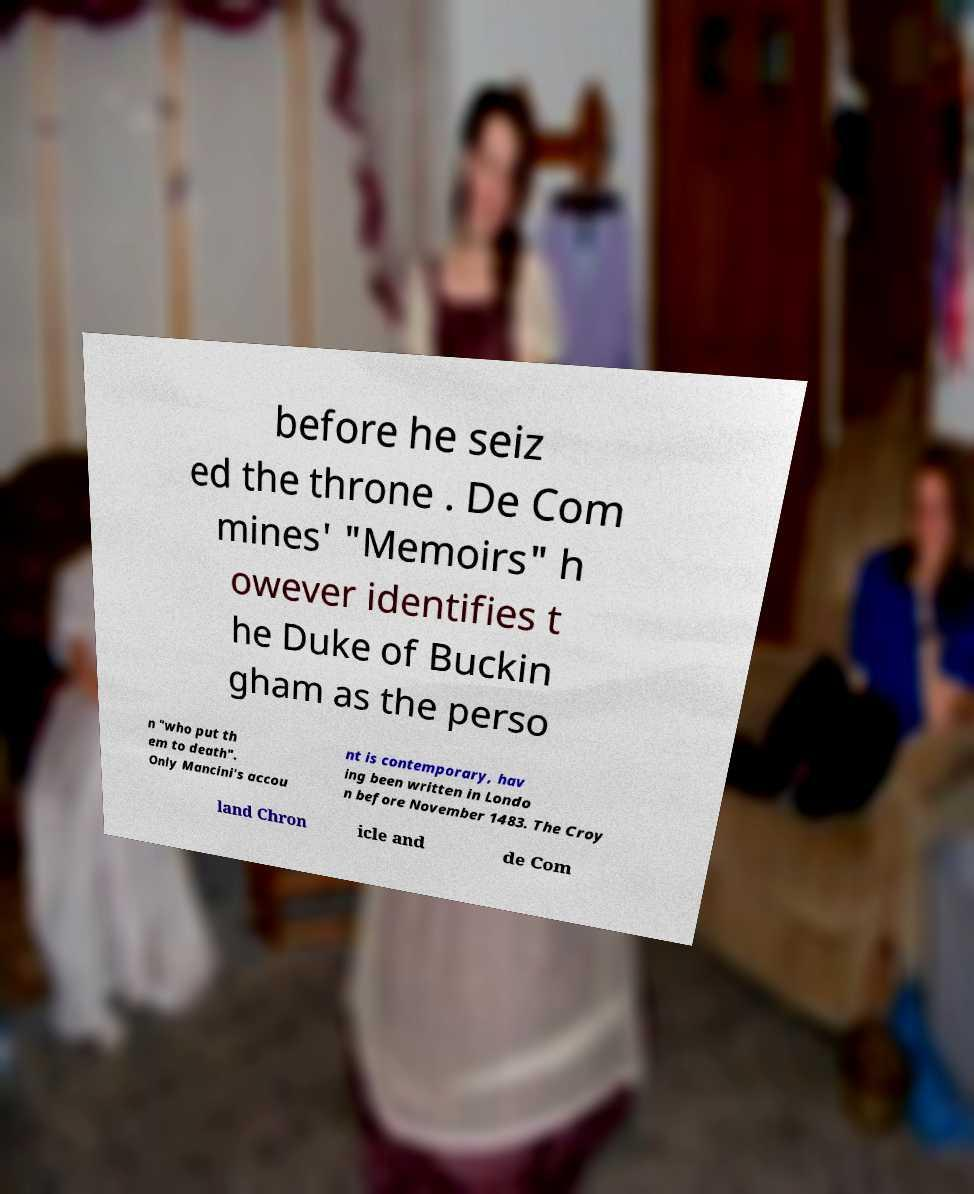Could you extract and type out the text from this image? before he seiz ed the throne . De Com mines' "Memoirs" h owever identifies t he Duke of Buckin gham as the perso n "who put th em to death". Only Mancini's accou nt is contemporary, hav ing been written in Londo n before November 1483. The Croy land Chron icle and de Com 